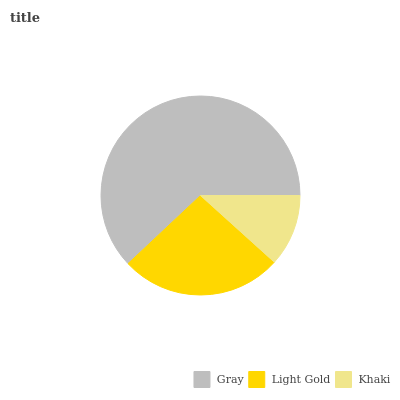Is Khaki the minimum?
Answer yes or no. Yes. Is Gray the maximum?
Answer yes or no. Yes. Is Light Gold the minimum?
Answer yes or no. No. Is Light Gold the maximum?
Answer yes or no. No. Is Gray greater than Light Gold?
Answer yes or no. Yes. Is Light Gold less than Gray?
Answer yes or no. Yes. Is Light Gold greater than Gray?
Answer yes or no. No. Is Gray less than Light Gold?
Answer yes or no. No. Is Light Gold the high median?
Answer yes or no. Yes. Is Light Gold the low median?
Answer yes or no. Yes. Is Khaki the high median?
Answer yes or no. No. Is Khaki the low median?
Answer yes or no. No. 